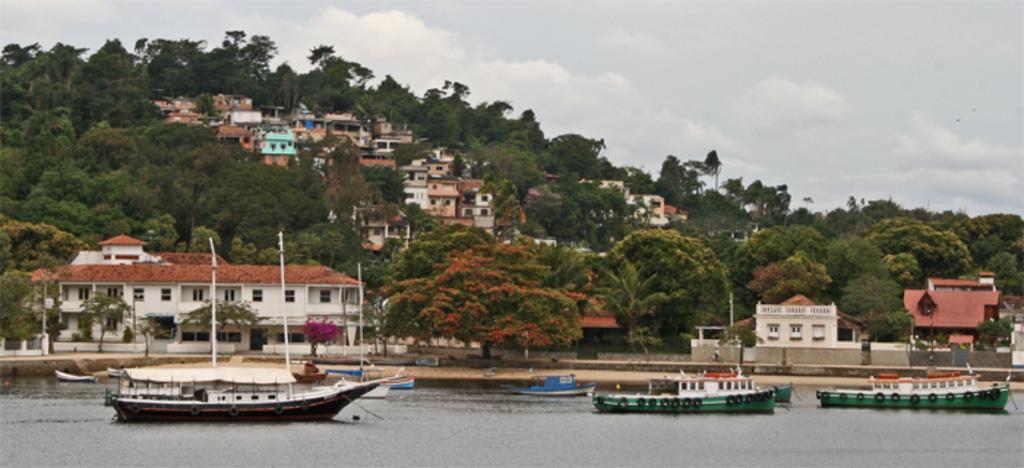How would you summarize this image in a sentence or two? In this picture there is a small boats in the river water. Behind there is a white and red color roof tile houses. In the background we can see a hilly area with many houses and trees. 